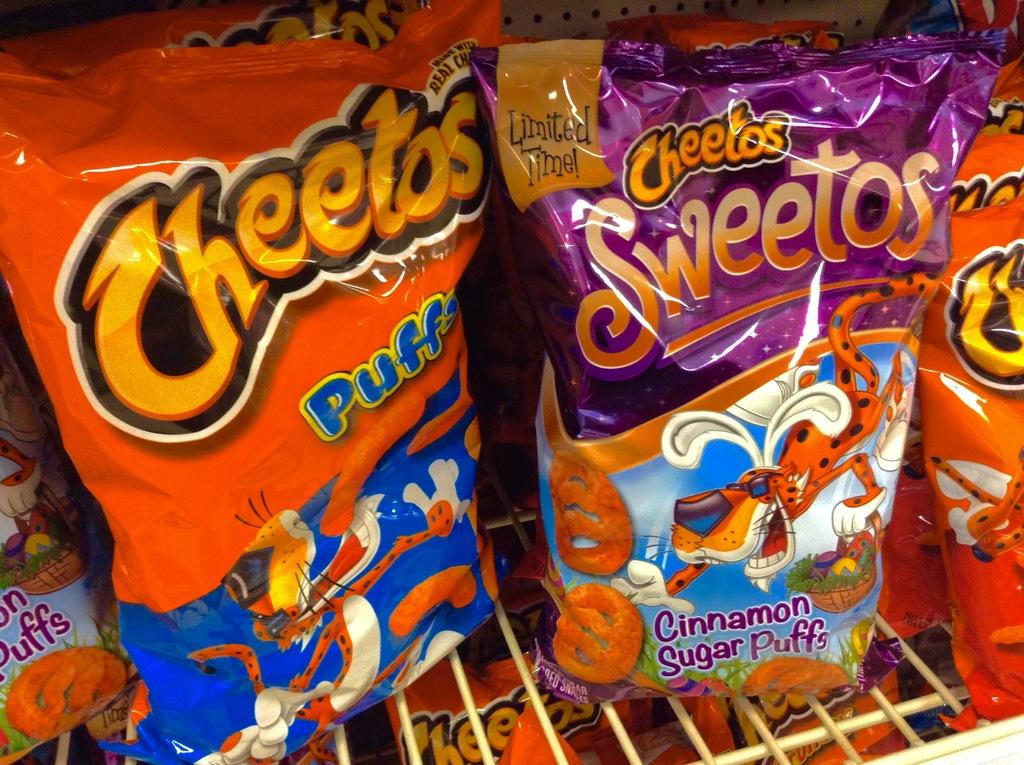What type of items can be seen in the image? There are food packets in the image. Can you describe the food packets in more detail? Unfortunately, the image does not provide enough detail to describe the food packets further. Where is the crown placed on the food packets in the image? There is no crown present on the food packets in the image. 